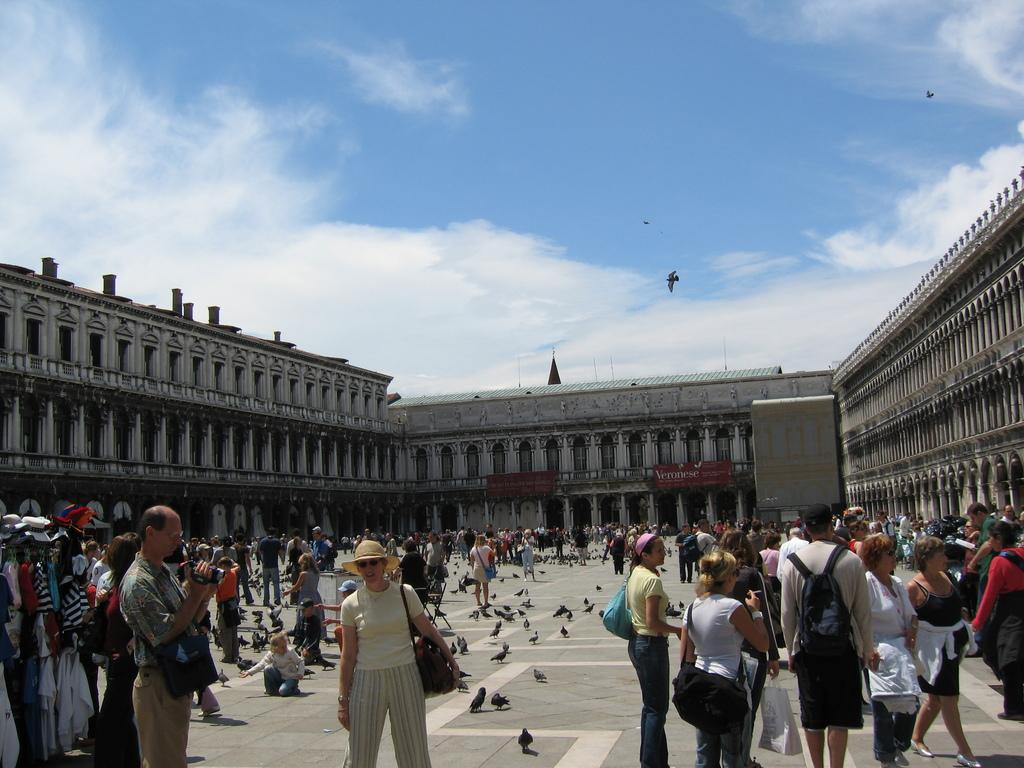What type of structures are visible in the image? There are buildings in the image. Are there any living beings present in the image? Yes, there are people standing in the image. What other animals can be seen in the image besides humans? There are birds on the ground in the image. What is visible at the top of the image? The sky is visible at the top of the image. What hobbies do the giraffes have in the image? There are no giraffes present in the image, so it is not possible to determine their hobbies. On which side of the image are the buildings located? The provided facts do not specify the side of the image where the buildings are located, so we cannot definitively answer this question. 